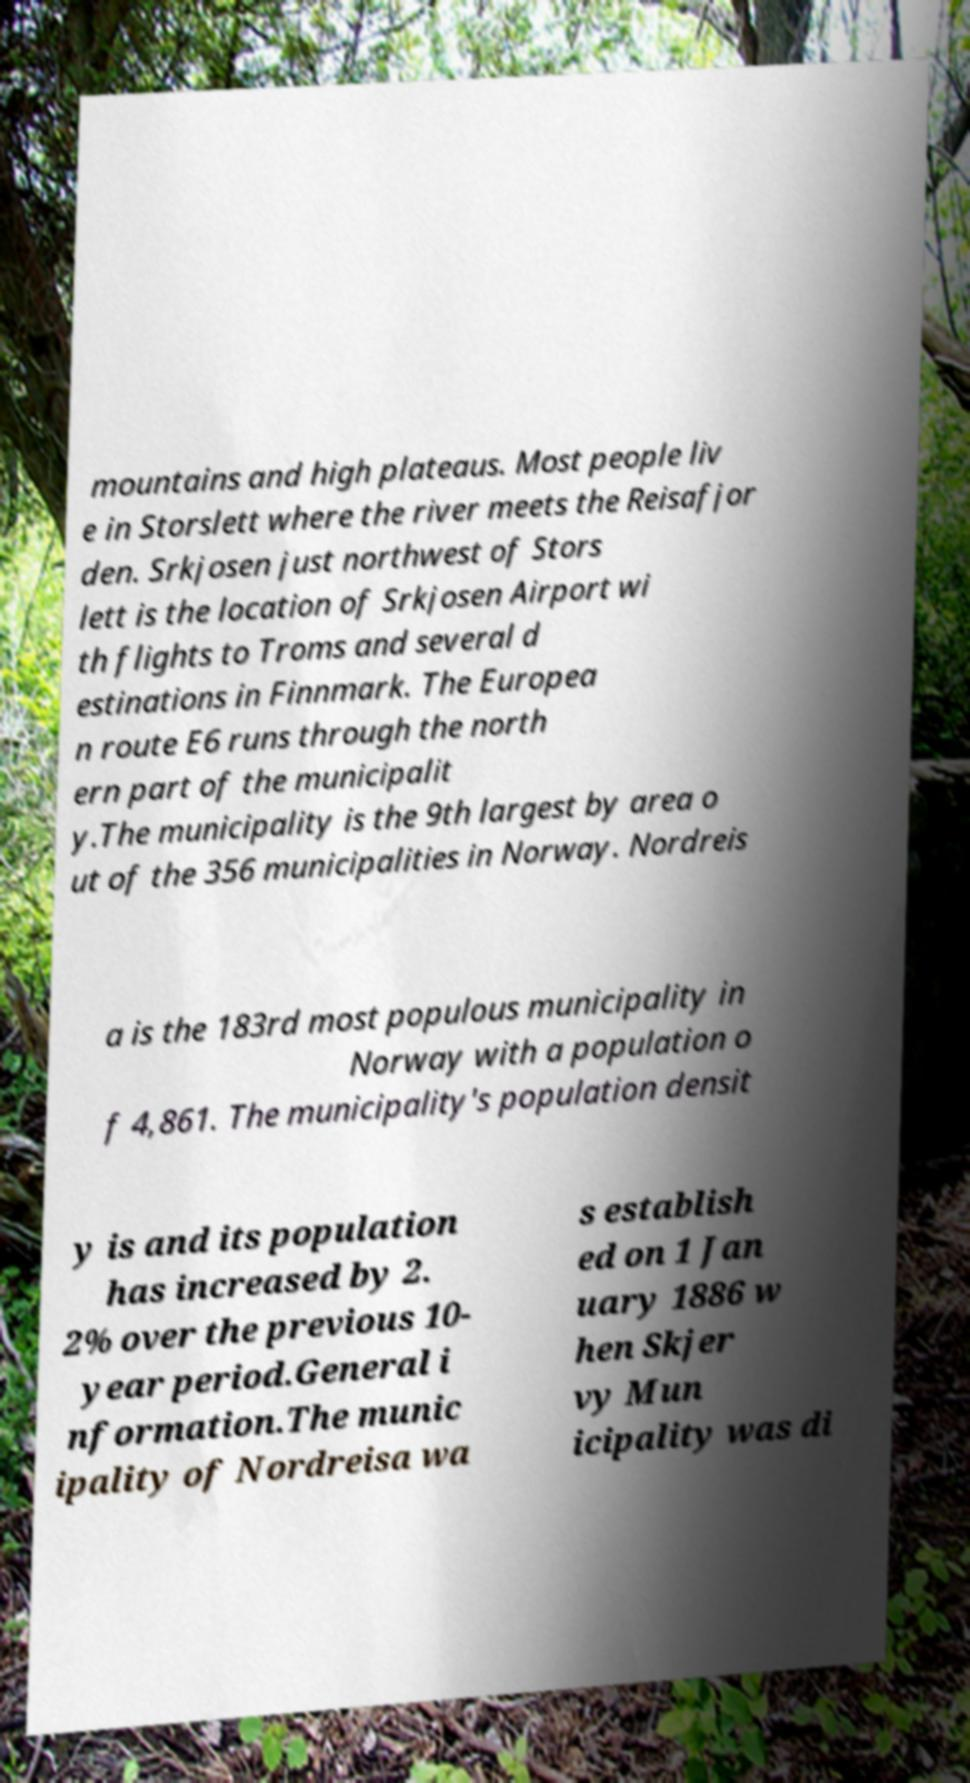For documentation purposes, I need the text within this image transcribed. Could you provide that? mountains and high plateaus. Most people liv e in Storslett where the river meets the Reisafjor den. Srkjosen just northwest of Stors lett is the location of Srkjosen Airport wi th flights to Troms and several d estinations in Finnmark. The Europea n route E6 runs through the north ern part of the municipalit y.The municipality is the 9th largest by area o ut of the 356 municipalities in Norway. Nordreis a is the 183rd most populous municipality in Norway with a population o f 4,861. The municipality's population densit y is and its population has increased by 2. 2% over the previous 10- year period.General i nformation.The munic ipality of Nordreisa wa s establish ed on 1 Jan uary 1886 w hen Skjer vy Mun icipality was di 